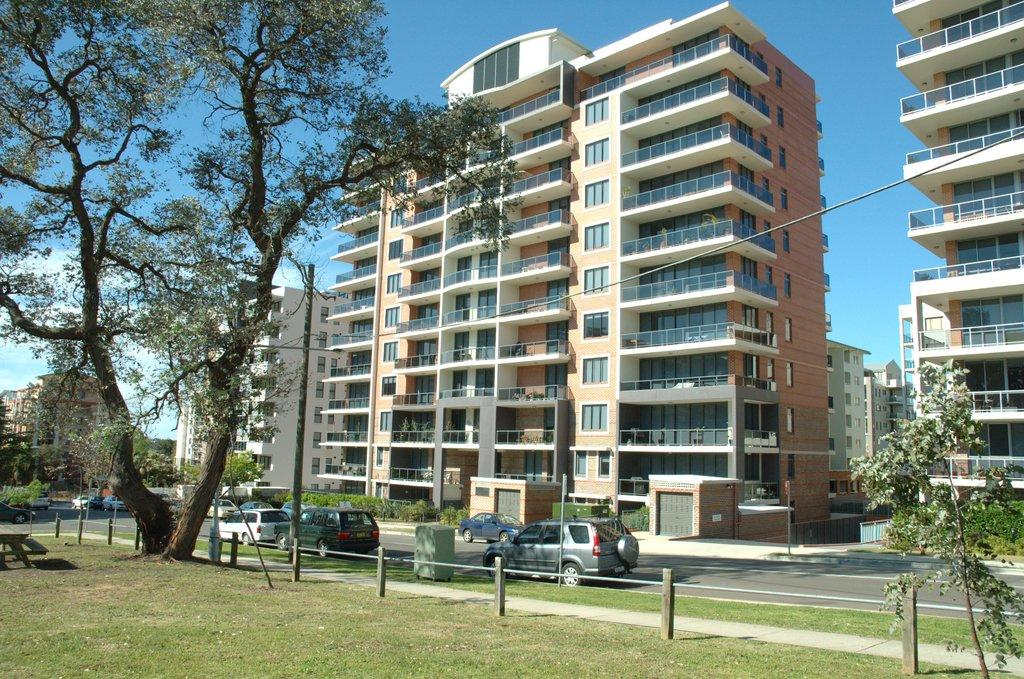What can be seen in the community in the image? There are many buildings in the community. What is happening on the road in front of the buildings? Vehicles are moving on the road in front of the buildings. What is located in front of the buildings? There is a garden in front of the buildings. What can be found in the garden? There is located in front of the buildings? What type of range can be seen in the image? There is no range present in the image; it shows a community with buildings, vehicles, a garden, and a tree. 